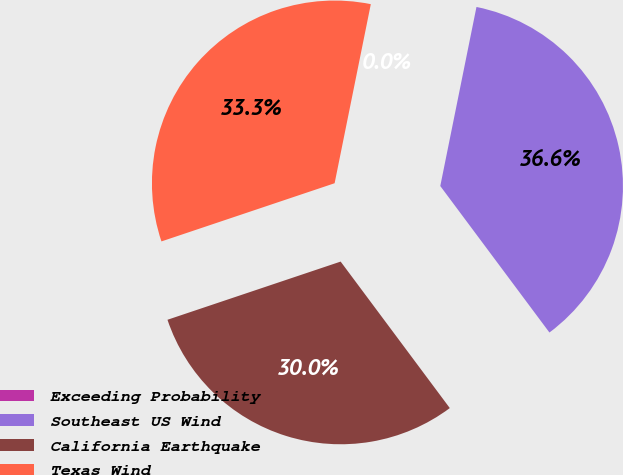<chart> <loc_0><loc_0><loc_500><loc_500><pie_chart><fcel>Exceeding Probability<fcel>Southeast US Wind<fcel>California Earthquake<fcel>Texas Wind<nl><fcel>0.0%<fcel>36.63%<fcel>30.03%<fcel>33.33%<nl></chart> 